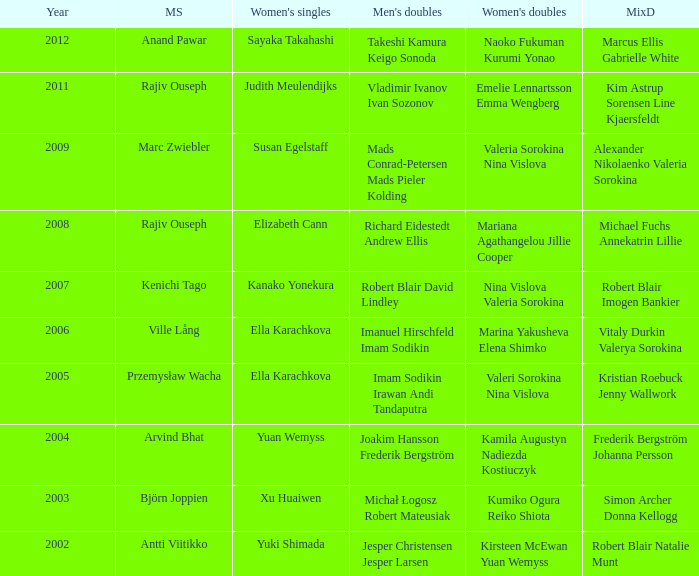Name the men's singles of marina yakusheva elena shimko Ville Lång. 